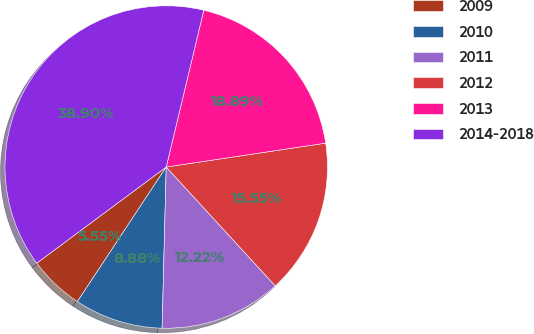<chart> <loc_0><loc_0><loc_500><loc_500><pie_chart><fcel>2009<fcel>2010<fcel>2011<fcel>2012<fcel>2013<fcel>2014-2018<nl><fcel>5.55%<fcel>8.88%<fcel>12.22%<fcel>15.55%<fcel>18.89%<fcel>38.9%<nl></chart> 